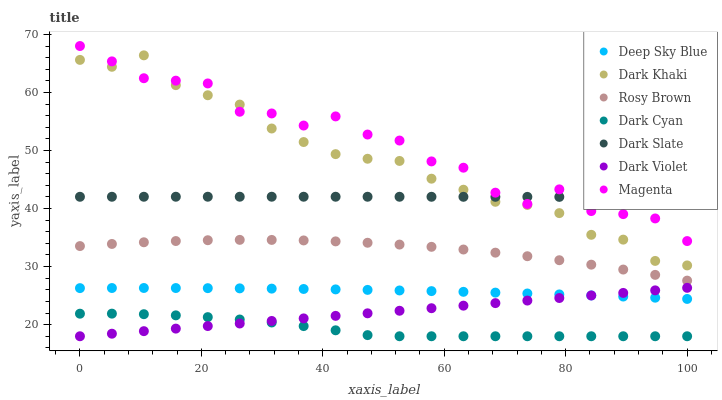Does Dark Cyan have the minimum area under the curve?
Answer yes or no. Yes. Does Magenta have the maximum area under the curve?
Answer yes or no. Yes. Does Dark Violet have the minimum area under the curve?
Answer yes or no. No. Does Dark Violet have the maximum area under the curve?
Answer yes or no. No. Is Dark Violet the smoothest?
Answer yes or no. Yes. Is Magenta the roughest?
Answer yes or no. Yes. Is Dark Khaki the smoothest?
Answer yes or no. No. Is Dark Khaki the roughest?
Answer yes or no. No. Does Dark Violet have the lowest value?
Answer yes or no. Yes. Does Dark Khaki have the lowest value?
Answer yes or no. No. Does Magenta have the highest value?
Answer yes or no. Yes. Does Dark Violet have the highest value?
Answer yes or no. No. Is Dark Cyan less than Dark Slate?
Answer yes or no. Yes. Is Magenta greater than Dark Violet?
Answer yes or no. Yes. Does Dark Slate intersect Magenta?
Answer yes or no. Yes. Is Dark Slate less than Magenta?
Answer yes or no. No. Is Dark Slate greater than Magenta?
Answer yes or no. No. Does Dark Cyan intersect Dark Slate?
Answer yes or no. No. 